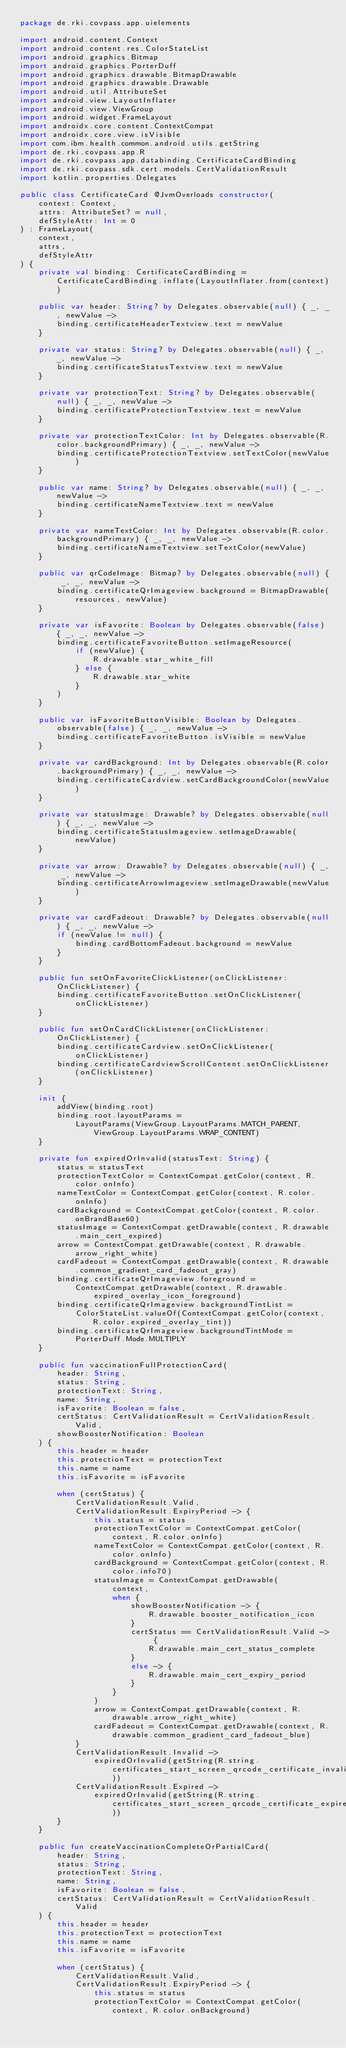<code> <loc_0><loc_0><loc_500><loc_500><_Kotlin_>package de.rki.covpass.app.uielements

import android.content.Context
import android.content.res.ColorStateList
import android.graphics.Bitmap
import android.graphics.PorterDuff
import android.graphics.drawable.BitmapDrawable
import android.graphics.drawable.Drawable
import android.util.AttributeSet
import android.view.LayoutInflater
import android.view.ViewGroup
import android.widget.FrameLayout
import androidx.core.content.ContextCompat
import androidx.core.view.isVisible
import com.ibm.health.common.android.utils.getString
import de.rki.covpass.app.R
import de.rki.covpass.app.databinding.CertificateCardBinding
import de.rki.covpass.sdk.cert.models.CertValidationResult
import kotlin.properties.Delegates

public class CertificateCard @JvmOverloads constructor(
    context: Context,
    attrs: AttributeSet? = null,
    defStyleAttr: Int = 0
) : FrameLayout(
    context,
    attrs,
    defStyleAttr
) {
    private val binding: CertificateCardBinding = CertificateCardBinding.inflate(LayoutInflater.from(context))

    public var header: String? by Delegates.observable(null) { _, _, newValue ->
        binding.certificateHeaderTextview.text = newValue
    }

    private var status: String? by Delegates.observable(null) { _, _, newValue ->
        binding.certificateStatusTextview.text = newValue
    }

    private var protectionText: String? by Delegates.observable(null) { _, _, newValue ->
        binding.certificateProtectionTextview.text = newValue
    }

    private var protectionTextColor: Int by Delegates.observable(R.color.backgroundPrimary) { _, _, newValue ->
        binding.certificateProtectionTextview.setTextColor(newValue)
    }

    public var name: String? by Delegates.observable(null) { _, _, newValue ->
        binding.certificateNameTextview.text = newValue
    }

    private var nameTextColor: Int by Delegates.observable(R.color.backgroundPrimary) { _, _, newValue ->
        binding.certificateNameTextview.setTextColor(newValue)
    }

    public var qrCodeImage: Bitmap? by Delegates.observable(null) { _, _, newValue ->
        binding.certificateQrImageview.background = BitmapDrawable(resources, newValue)
    }

    private var isFavorite: Boolean by Delegates.observable(false) { _, _, newValue ->
        binding.certificateFavoriteButton.setImageResource(
            if (newValue) {
                R.drawable.star_white_fill
            } else {
                R.drawable.star_white
            }
        )
    }

    public var isFavoriteButtonVisible: Boolean by Delegates.observable(false) { _, _, newValue ->
        binding.certificateFavoriteButton.isVisible = newValue
    }

    private var cardBackground: Int by Delegates.observable(R.color.backgroundPrimary) { _, _, newValue ->
        binding.certificateCardview.setCardBackgroundColor(newValue)
    }

    private var statusImage: Drawable? by Delegates.observable(null) { _, _, newValue ->
        binding.certificateStatusImageview.setImageDrawable(newValue)
    }

    private var arrow: Drawable? by Delegates.observable(null) { _, _, newValue ->
        binding.certificateArrowImageview.setImageDrawable(newValue)
    }

    private var cardFadeout: Drawable? by Delegates.observable(null) { _, _, newValue ->
        if (newValue != null) {
            binding.cardBottomFadeout.background = newValue
        }
    }

    public fun setOnFavoriteClickListener(onClickListener: OnClickListener) {
        binding.certificateFavoriteButton.setOnClickListener(onClickListener)
    }

    public fun setOnCardClickListener(onClickListener: OnClickListener) {
        binding.certificateCardview.setOnClickListener(onClickListener)
        binding.certificateCardviewScrollContent.setOnClickListener(onClickListener)
    }

    init {
        addView(binding.root)
        binding.root.layoutParams =
            LayoutParams(ViewGroup.LayoutParams.MATCH_PARENT, ViewGroup.LayoutParams.WRAP_CONTENT)
    }

    private fun expiredOrInvalid(statusText: String) {
        status = statusText
        protectionTextColor = ContextCompat.getColor(context, R.color.onInfo)
        nameTextColor = ContextCompat.getColor(context, R.color.onInfo)
        cardBackground = ContextCompat.getColor(context, R.color.onBrandBase60)
        statusImage = ContextCompat.getDrawable(context, R.drawable.main_cert_expired)
        arrow = ContextCompat.getDrawable(context, R.drawable.arrow_right_white)
        cardFadeout = ContextCompat.getDrawable(context, R.drawable.common_gradient_card_fadeout_gray)
        binding.certificateQrImageview.foreground =
            ContextCompat.getDrawable(context, R.drawable.expired_overlay_icon_foreground)
        binding.certificateQrImageview.backgroundTintList =
            ColorStateList.valueOf(ContextCompat.getColor(context, R.color.expired_overlay_tint))
        binding.certificateQrImageview.backgroundTintMode = PorterDuff.Mode.MULTIPLY
    }

    public fun vaccinationFullProtectionCard(
        header: String,
        status: String,
        protectionText: String,
        name: String,
        isFavorite: Boolean = false,
        certStatus: CertValidationResult = CertValidationResult.Valid,
        showBoosterNotification: Boolean
    ) {
        this.header = header
        this.protectionText = protectionText
        this.name = name
        this.isFavorite = isFavorite

        when (certStatus) {
            CertValidationResult.Valid,
            CertValidationResult.ExpiryPeriod -> {
                this.status = status
                protectionTextColor = ContextCompat.getColor(context, R.color.onInfo)
                nameTextColor = ContextCompat.getColor(context, R.color.onInfo)
                cardBackground = ContextCompat.getColor(context, R.color.info70)
                statusImage = ContextCompat.getDrawable(
                    context,
                    when {
                        showBoosterNotification -> {
                            R.drawable.booster_notification_icon
                        }
                        certStatus == CertValidationResult.Valid -> {
                            R.drawable.main_cert_status_complete
                        }
                        else -> {
                            R.drawable.main_cert_expiry_period
                        }
                    }
                )
                arrow = ContextCompat.getDrawable(context, R.drawable.arrow_right_white)
                cardFadeout = ContextCompat.getDrawable(context, R.drawable.common_gradient_card_fadeout_blue)
            }
            CertValidationResult.Invalid ->
                expiredOrInvalid(getString(R.string.certificates_start_screen_qrcode_certificate_invalid_subtitle))
            CertValidationResult.Expired ->
                expiredOrInvalid(getString(R.string.certificates_start_screen_qrcode_certificate_expired_subtitle))
        }
    }

    public fun createVaccinationCompleteOrPartialCard(
        header: String,
        status: String,
        protectionText: String,
        name: String,
        isFavorite: Boolean = false,
        certStatus: CertValidationResult = CertValidationResult.Valid
    ) {
        this.header = header
        this.protectionText = protectionText
        this.name = name
        this.isFavorite = isFavorite

        when (certStatus) {
            CertValidationResult.Valid,
            CertValidationResult.ExpiryPeriod -> {
                this.status = status
                protectionTextColor = ContextCompat.getColor(context, R.color.onBackground)</code> 